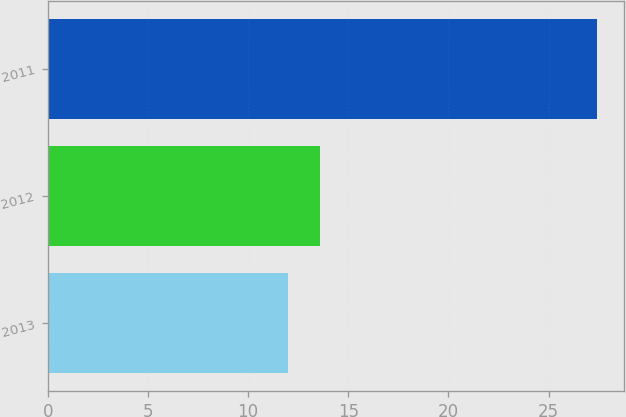<chart> <loc_0><loc_0><loc_500><loc_500><bar_chart><fcel>2013<fcel>2012<fcel>2011<nl><fcel>12<fcel>13.6<fcel>27.4<nl></chart> 